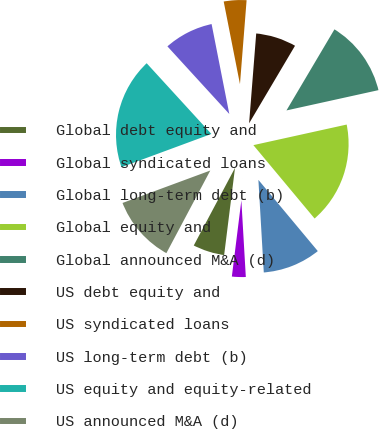Convert chart to OTSL. <chart><loc_0><loc_0><loc_500><loc_500><pie_chart><fcel>Global debt equity and<fcel>Global syndicated loans<fcel>Global long-term debt (b)<fcel>Global equity and<fcel>Global announced M&A (d)<fcel>US debt equity and<fcel>US syndicated loans<fcel>US long-term debt (b)<fcel>US equity and equity-related<fcel>US announced M&A (d)<nl><fcel>5.8%<fcel>2.9%<fcel>10.14%<fcel>17.39%<fcel>13.04%<fcel>7.25%<fcel>4.35%<fcel>8.7%<fcel>18.84%<fcel>11.59%<nl></chart> 